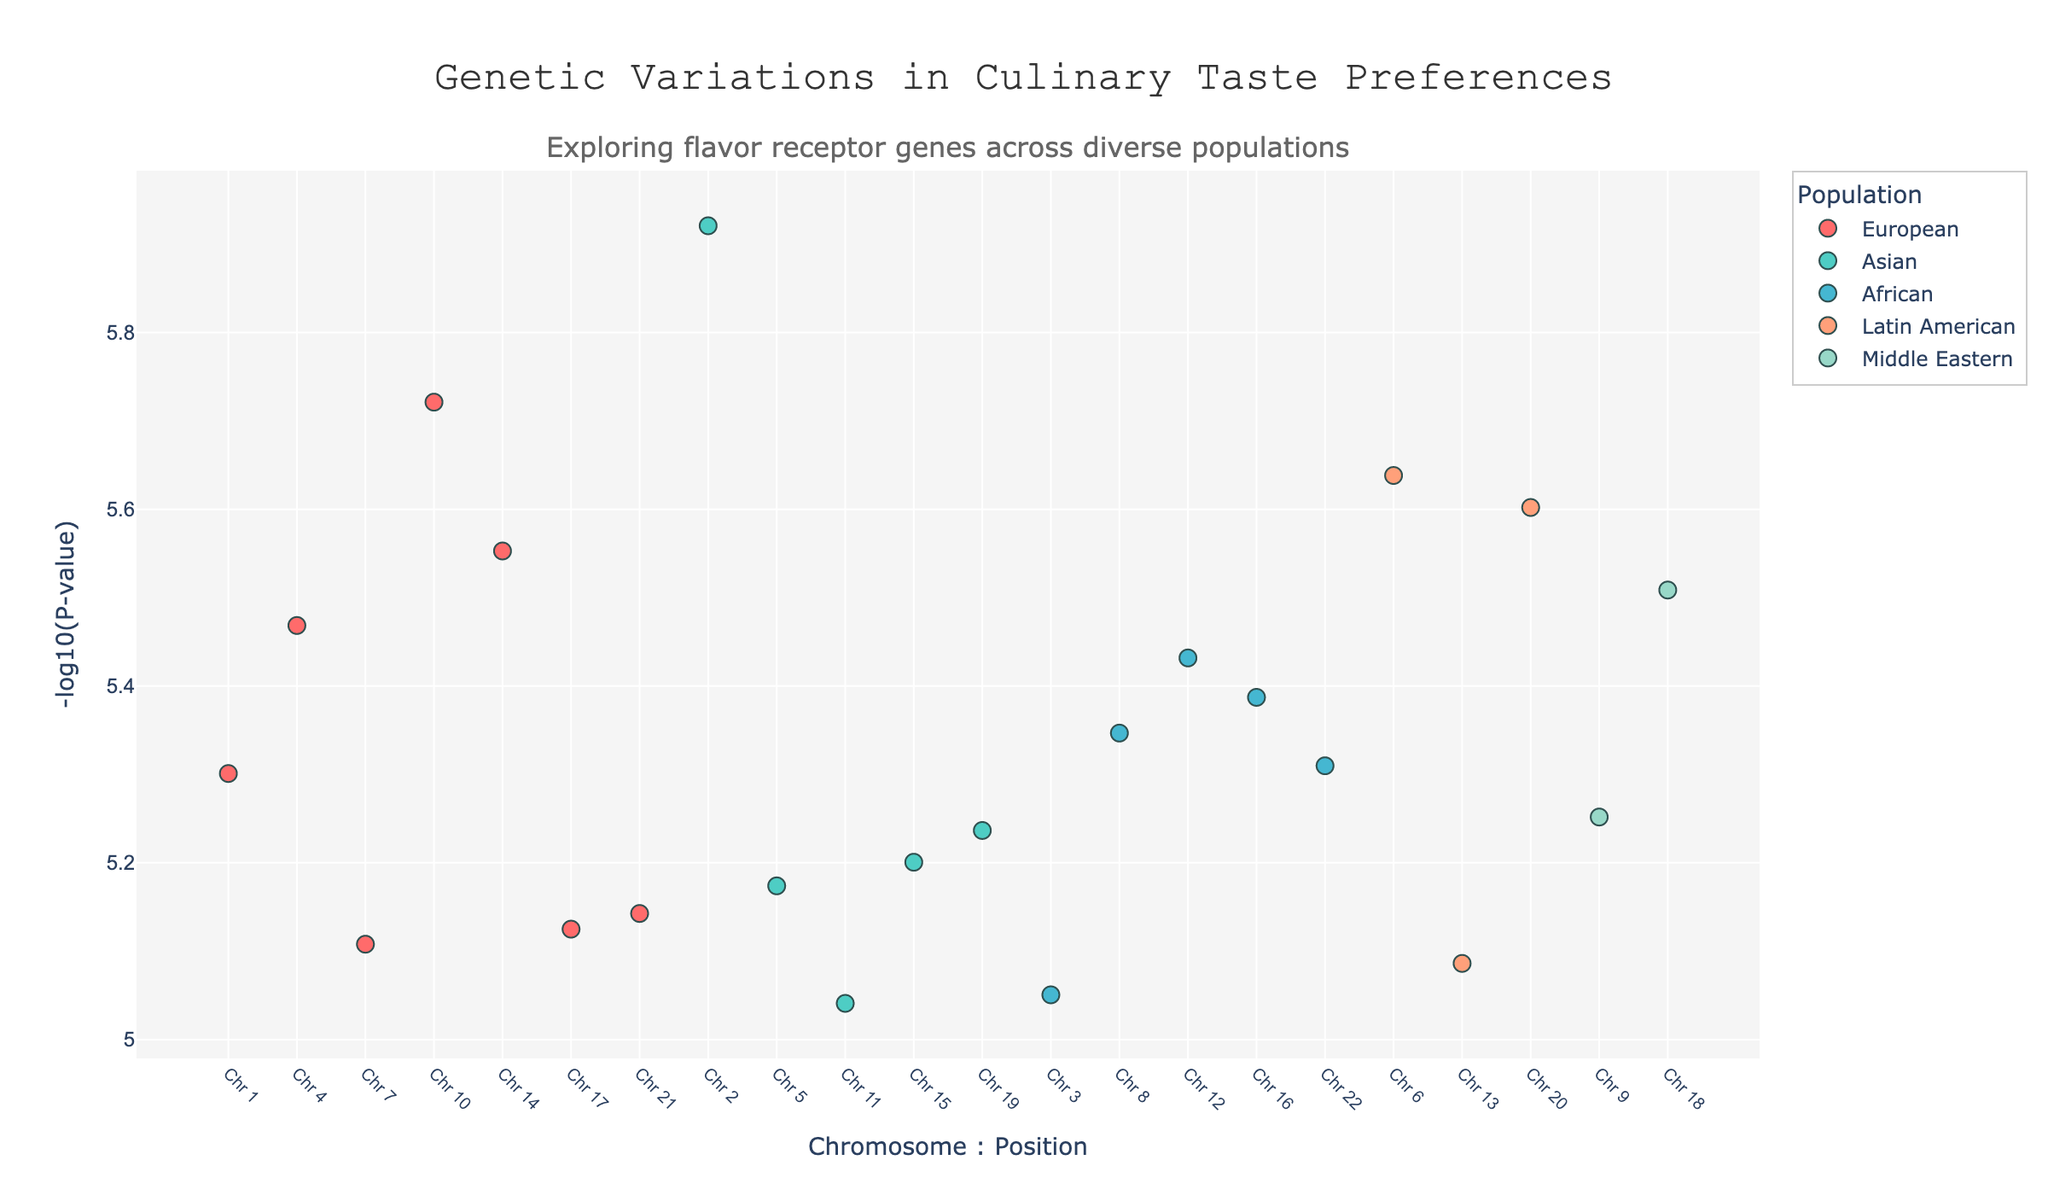What is the title of the plot? The title of the plot is found at the top center and reads "Genetic Variations in Culinary Taste Preferences".
Answer: Genetic Variations in Culinary Taste Preferences Which population is represented by the color light cyan? The color light cyan is used for the Asian population according to the color map presented in the legend.
Answer: Asian How many flavor receptors are displayed for the European population? By examining the scatter plots and filtering by the European population in the hover text, there are six distinct flavor receptors: Umami, Bitter, Salt, Truffle, Citrus, Mint.
Answer: six What is the range of the y-axis? The y-axis is labeled with "-log10(P-value)" and spans from around 0 to a bit above 8.
Answer: 0 to slightly above 8 Which flavor receptor gene has the lowest p-value in the European population? By analyzing the data points and corresponding hover text for the European population, the OR7D4 gene (Truffle flavor receptor) has the lowest p-value at 0.0000019.
Answer: OR7D4 (Truffle) Which population has the highest peak in the Manhattan plot? The highest peak corresponds to the Asian population, with the TAS1R2 gene (Sweet flavor receptor) at chromosome 2, position 34000000, with the highest y-axis value (-log10(0.0000012)).
Answer: Asian Compare the p-values of the bitter flavor receptor between the European and African populations. Which population shows a lower p-value? For Bitter, the European population has the gene TAS2R38 at p-value 0.0000034, while the African population has the genes TAS2R43 at p-value 0.0000037 and TAS2R31 at p-value 0.0000082. The European population shows a lower p-value.
Answer: European What is the median p-value for the flavor receptors in the Asian population? The Asian population has flavor receptors with p-values: 0.0000012, 0.0000067, 0.0000091, 0.0000063, 0.0000058. Ordering these values: 0.0000012, 0.0000058, 0.0000063, 0.0000067, 0.0000091, the median is the middle value, which is 0.0000063.
Answer: 0.0000063 Which flavor receptor gene can be found on chromosome 16? By locating chromosome 16 and referring to the corresponding data point and hover text, it is the SLC2A4 gene associated with the glucose flavor receptor.
Answer: SLC2A4 (Glucose) 